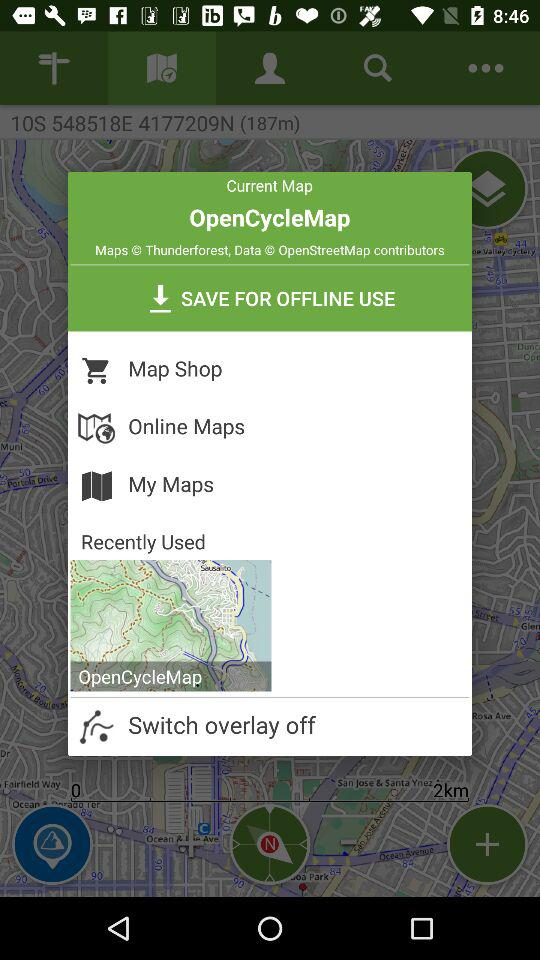What is the application name? The application name is "OpenCycleMap". 